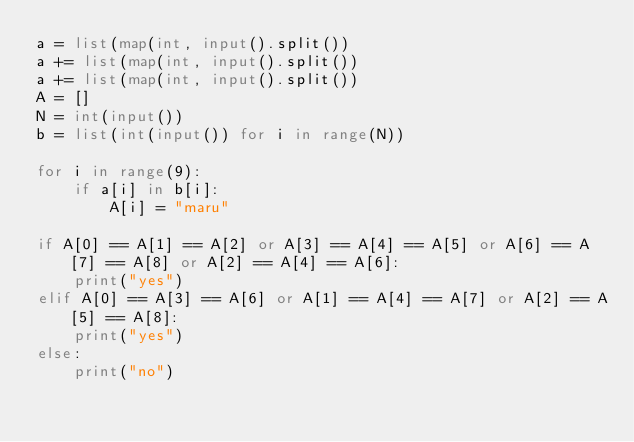Convert code to text. <code><loc_0><loc_0><loc_500><loc_500><_Python_>a = list(map(int, input().split())
a += list(map(int, input().split())
a += list(map(int, input().split())
A = []
N = int(input())
b = list(int(input()) for i in range(N))

for i in range(9):
    if a[i] in b[i]:
        A[i] = "maru"

if A[0] == A[1] == A[2] or A[3] == A[4] == A[5] or A[6] == A[7] == A[8] or A[2] == A[4] == A[6]:
    print("yes")
elif A[0] == A[3] == A[6] or A[1] == A[4] == A[7] or A[2] == A[5] == A[8]:
    print("yes")
else:
    print("no")  </code> 